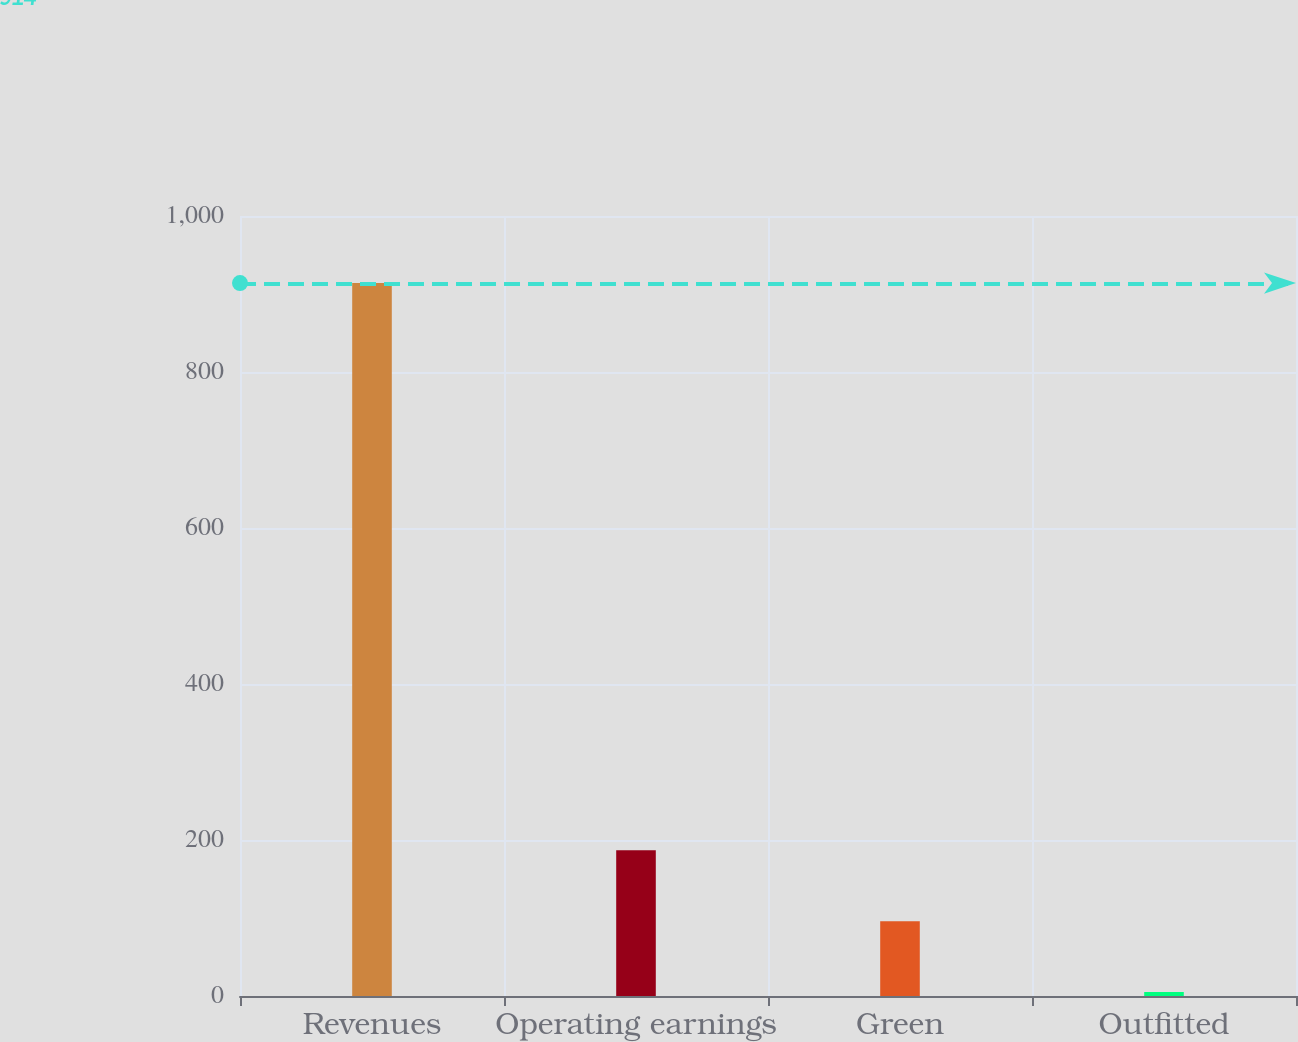Convert chart. <chart><loc_0><loc_0><loc_500><loc_500><bar_chart><fcel>Revenues<fcel>Operating earnings<fcel>Green<fcel>Outfitted<nl><fcel>914<fcel>186.8<fcel>95.9<fcel>5<nl></chart> 